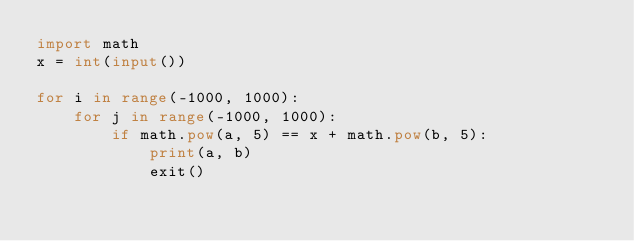Convert code to text. <code><loc_0><loc_0><loc_500><loc_500><_Python_>import math
x = int(input())

for i in range(-1000, 1000):
    for j in range(-1000, 1000):
        if math.pow(a, 5) == x + math.pow(b, 5):
            print(a, b)
            exit()</code> 